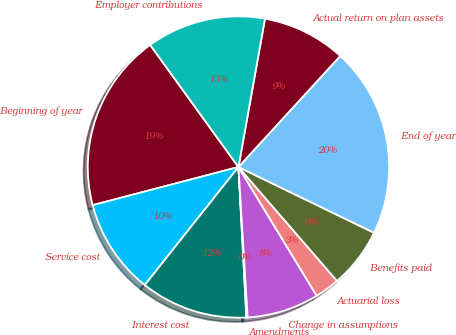<chart> <loc_0><loc_0><loc_500><loc_500><pie_chart><fcel>Beginning of year<fcel>Service cost<fcel>Interest cost<fcel>Amendments<fcel>Change in assumptions<fcel>Actuarial loss<fcel>Benefits paid<fcel>End of year<fcel>Actual return on plan assets<fcel>Employer contributions<nl><fcel>19.11%<fcel>10.25%<fcel>11.52%<fcel>0.13%<fcel>7.72%<fcel>2.66%<fcel>6.46%<fcel>20.38%<fcel>8.99%<fcel>12.78%<nl></chart> 